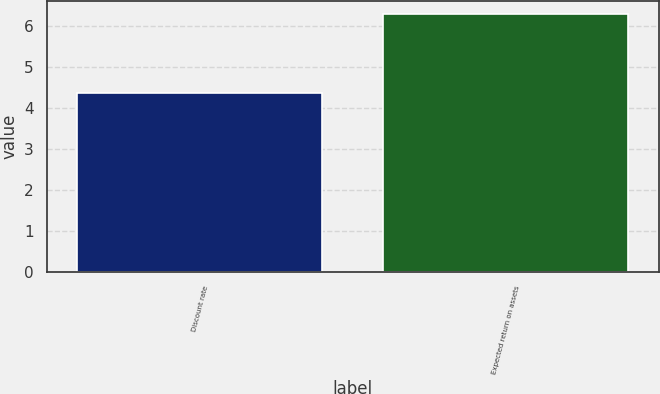<chart> <loc_0><loc_0><loc_500><loc_500><bar_chart><fcel>Discount rate<fcel>Expected return on assets<nl><fcel>4.35<fcel>6.29<nl></chart> 